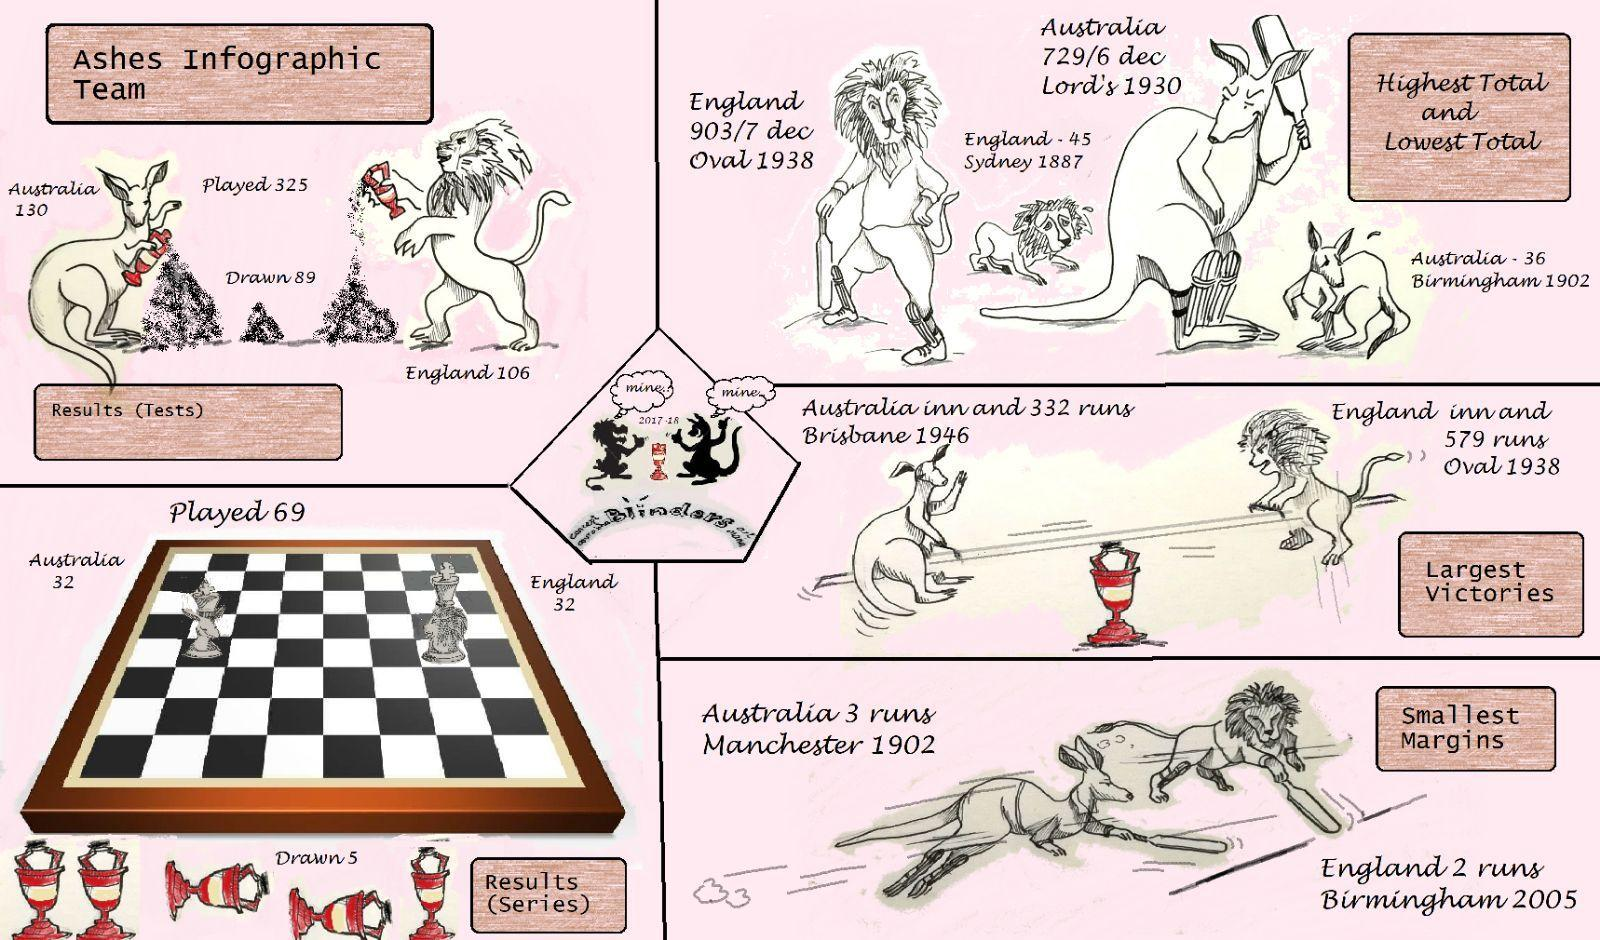How many matches won by Australia?
Answer the question with a short phrase. 130 In which year the highest total scored? 1938 